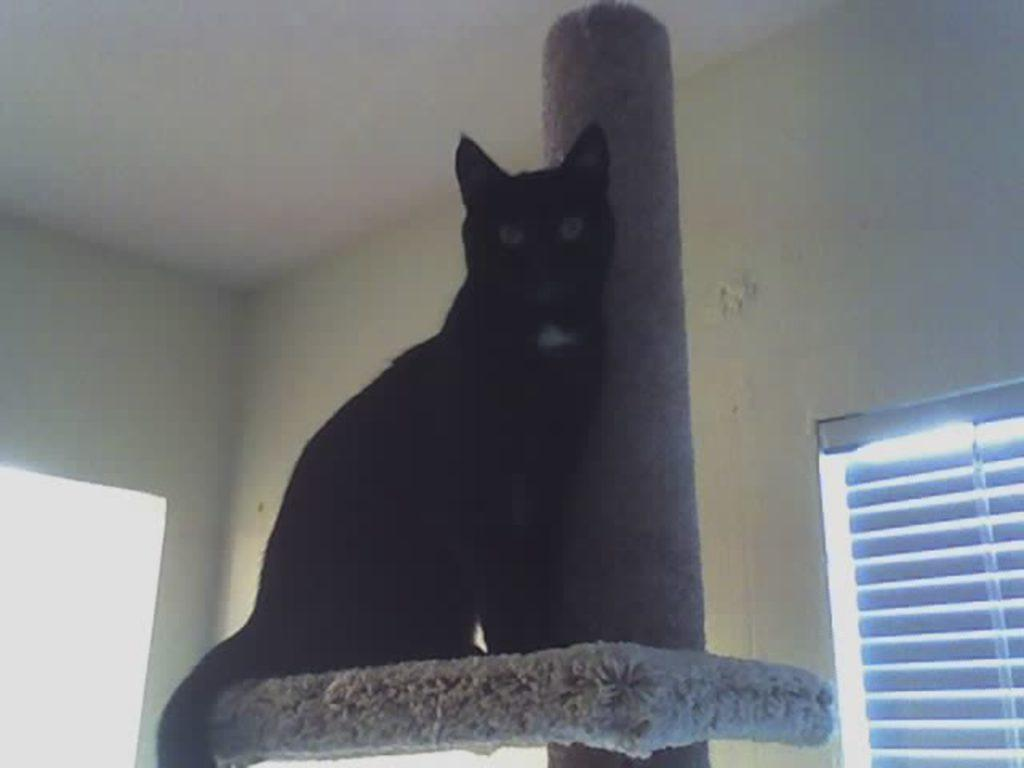What animal is present in the image? There is a cat in the image. Where is the cat located? The cat is on a platform. What can be seen in the background of the image? There is a wall, a pillar, a roof, and a window in the background of the image. What type of sand can be seen on the hill in the image? There is no sand or hill present in the image. What does the cat smell in the image? The facts provided do not mention anything about the cat's sense of smell, so we cannot determine what the cat smells in the image. 